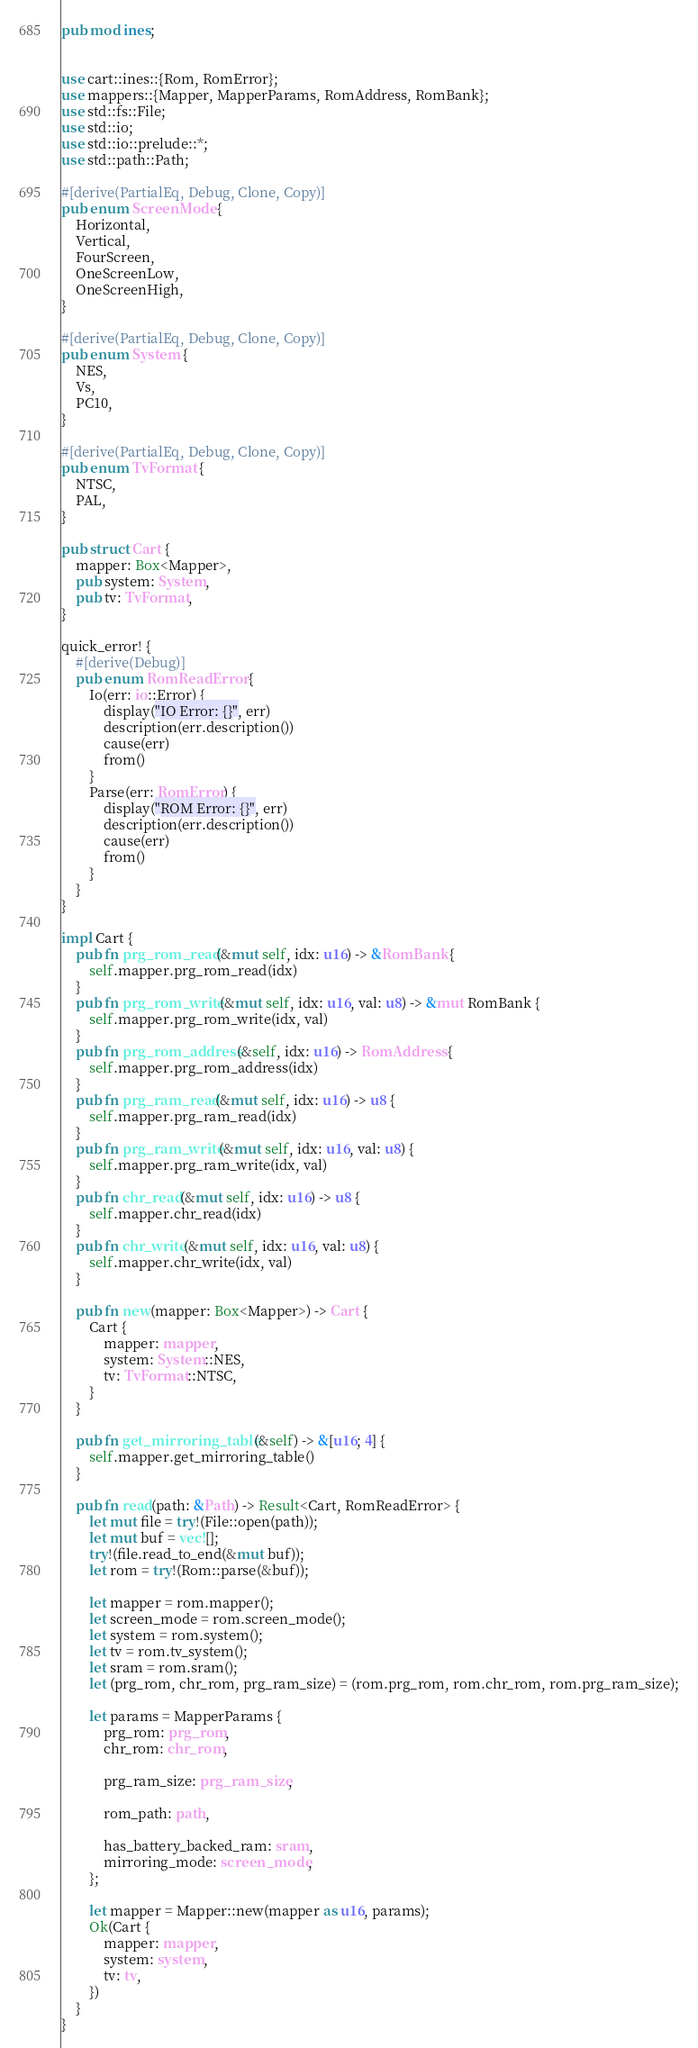Convert code to text. <code><loc_0><loc_0><loc_500><loc_500><_Rust_>pub mod ines;


use cart::ines::{Rom, RomError};
use mappers::{Mapper, MapperParams, RomAddress, RomBank};
use std::fs::File;
use std::io;
use std::io::prelude::*;
use std::path::Path;

#[derive(PartialEq, Debug, Clone, Copy)]
pub enum ScreenMode {
    Horizontal,
    Vertical,
    FourScreen,
    OneScreenLow,
    OneScreenHigh,
}

#[derive(PartialEq, Debug, Clone, Copy)]
pub enum System {
    NES,
    Vs,
    PC10,
}

#[derive(PartialEq, Debug, Clone, Copy)]
pub enum TvFormat {
    NTSC,
    PAL,
}

pub struct Cart {
    mapper: Box<Mapper>,
    pub system: System,
    pub tv: TvFormat,
}

quick_error! {
    #[derive(Debug)]
    pub enum RomReadError {
        Io(err: io::Error) {
            display("IO Error: {}", err)
            description(err.description())
            cause(err)
            from()
        }
        Parse(err: RomError) {
            display("ROM Error: {}", err)
            description(err.description())
            cause(err)
            from()
        }
    }
}

impl Cart {
    pub fn prg_rom_read(&mut self, idx: u16) -> &RomBank {
        self.mapper.prg_rom_read(idx)
    }
    pub fn prg_rom_write(&mut self, idx: u16, val: u8) -> &mut RomBank {
        self.mapper.prg_rom_write(idx, val)
    }
    pub fn prg_rom_address(&self, idx: u16) -> RomAddress {
        self.mapper.prg_rom_address(idx)
    }
    pub fn prg_ram_read(&mut self, idx: u16) -> u8 {
        self.mapper.prg_ram_read(idx)
    }
    pub fn prg_ram_write(&mut self, idx: u16, val: u8) {
        self.mapper.prg_ram_write(idx, val)
    }
    pub fn chr_read(&mut self, idx: u16) -> u8 {
        self.mapper.chr_read(idx)
    }
    pub fn chr_write(&mut self, idx: u16, val: u8) {
        self.mapper.chr_write(idx, val)
    }

    pub fn new(mapper: Box<Mapper>) -> Cart {
        Cart {
            mapper: mapper,
            system: System::NES,
            tv: TvFormat::NTSC,
        }
    }

    pub fn get_mirroring_table(&self) -> &[u16; 4] {
        self.mapper.get_mirroring_table()
    }

    pub fn read(path: &Path) -> Result<Cart, RomReadError> {
        let mut file = try!(File::open(path));
        let mut buf = vec![];
        try!(file.read_to_end(&mut buf));
        let rom = try!(Rom::parse(&buf));

        let mapper = rom.mapper();
        let screen_mode = rom.screen_mode();
        let system = rom.system();
        let tv = rom.tv_system();
        let sram = rom.sram();
        let (prg_rom, chr_rom, prg_ram_size) = (rom.prg_rom, rom.chr_rom, rom.prg_ram_size);

        let params = MapperParams {
            prg_rom: prg_rom,
            chr_rom: chr_rom,

            prg_ram_size: prg_ram_size,

            rom_path: path,

            has_battery_backed_ram: sram,
            mirroring_mode: screen_mode,
        };

        let mapper = Mapper::new(mapper as u16, params);
        Ok(Cart {
            mapper: mapper,
            system: system,
            tv: tv,
        })
    }
}
</code> 